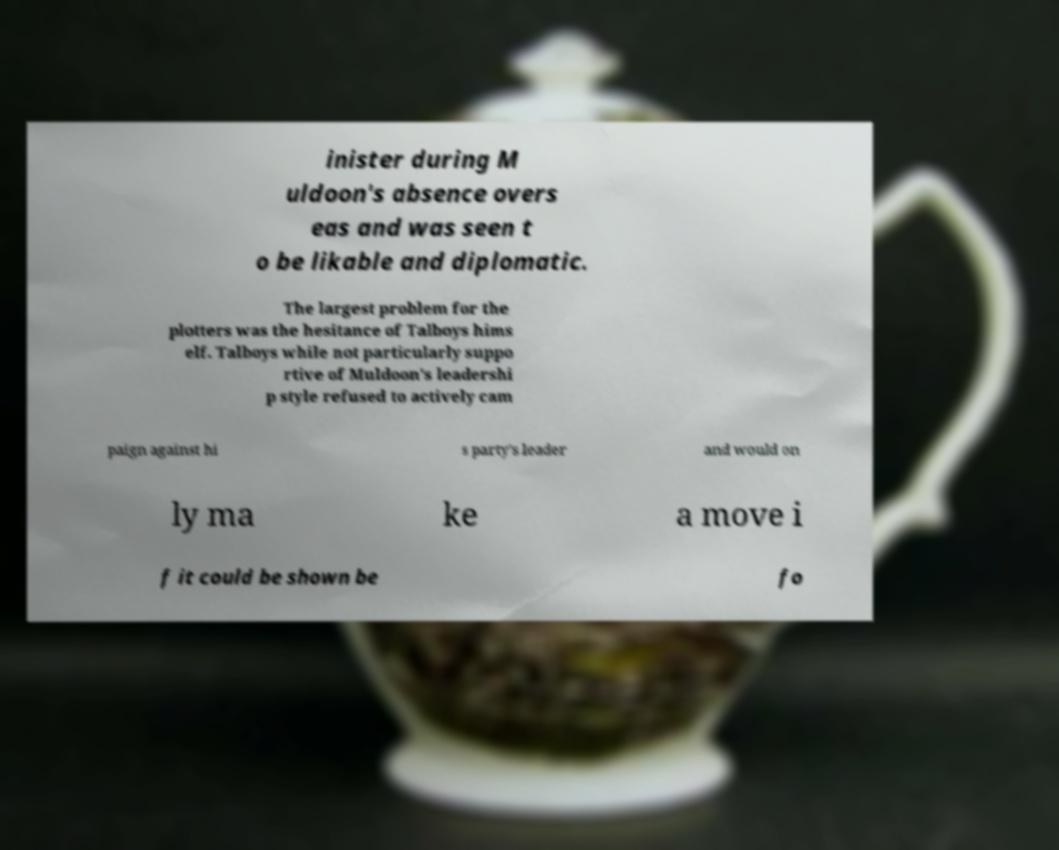Could you extract and type out the text from this image? inister during M uldoon's absence overs eas and was seen t o be likable and diplomatic. The largest problem for the plotters was the hesitance of Talboys hims elf. Talboys while not particularly suppo rtive of Muldoon's leadershi p style refused to actively cam paign against hi s party's leader and would on ly ma ke a move i f it could be shown be fo 